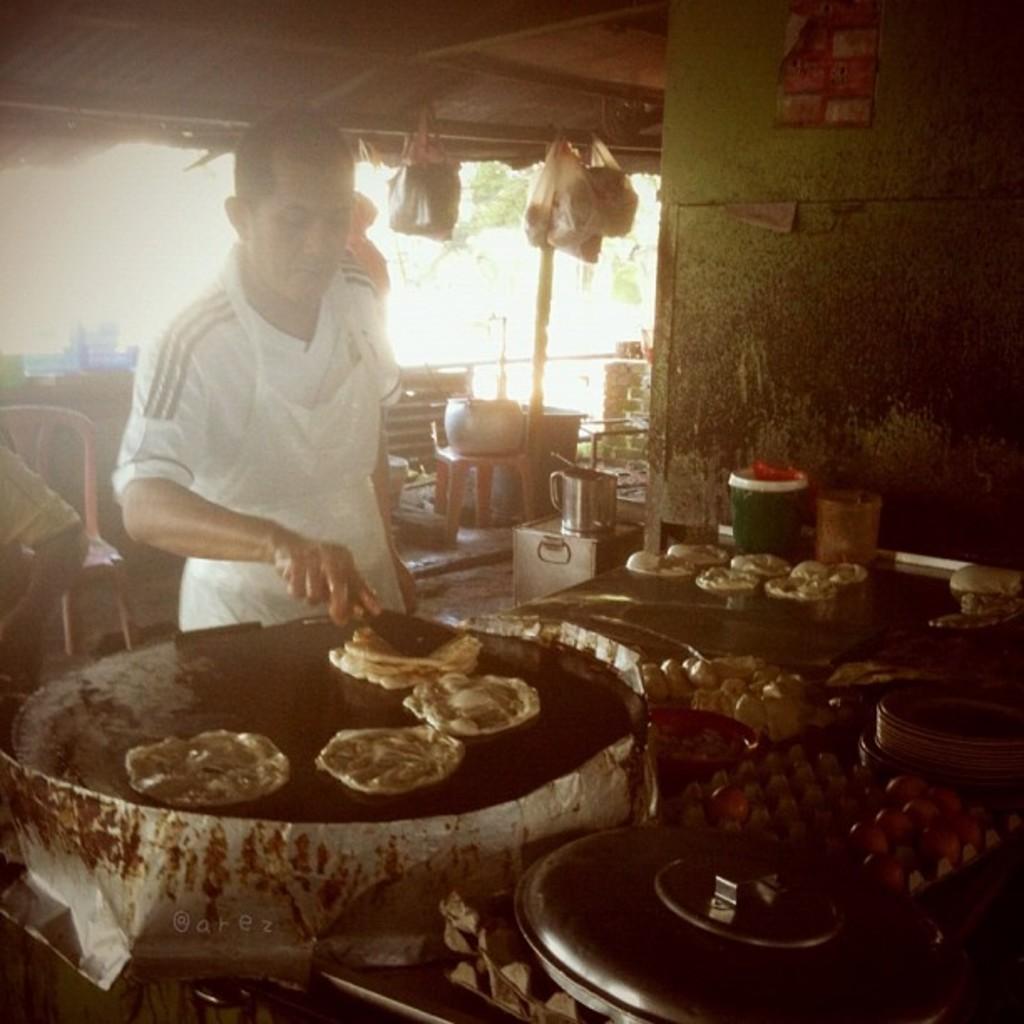How would you summarize this image in a sentence or two? In the picture we can see a man standing and cooking on the pan, and we can also see some food items on the table, boxes and some food packets which are hanged to the ceiling, man is wearing a white T-shirt with apron. 